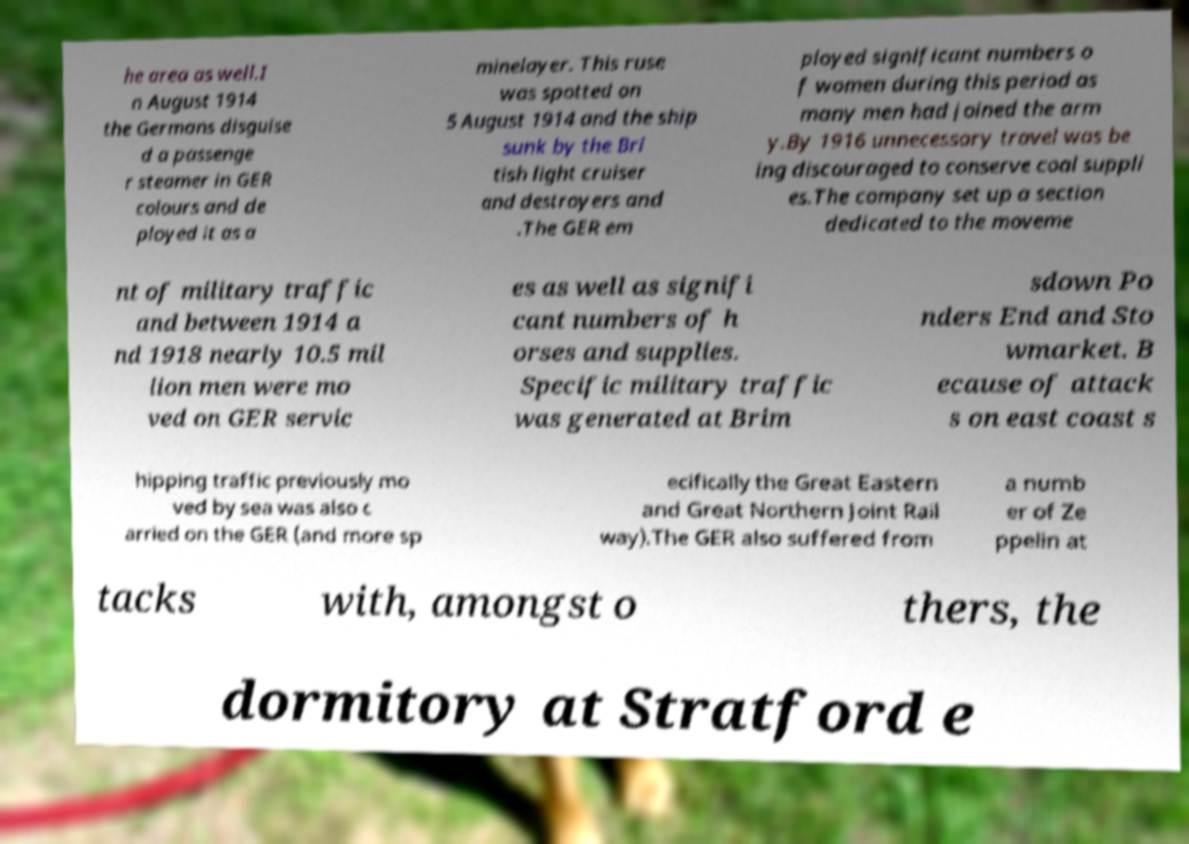Can you read and provide the text displayed in the image?This photo seems to have some interesting text. Can you extract and type it out for me? he area as well.I n August 1914 the Germans disguise d a passenge r steamer in GER colours and de ployed it as a minelayer. This ruse was spotted on 5 August 1914 and the ship sunk by the Bri tish light cruiser and destroyers and .The GER em ployed significant numbers o f women during this period as many men had joined the arm y.By 1916 unnecessary travel was be ing discouraged to conserve coal suppli es.The company set up a section dedicated to the moveme nt of military traffic and between 1914 a nd 1918 nearly 10.5 mil lion men were mo ved on GER servic es as well as signifi cant numbers of h orses and supplies. Specific military traffic was generated at Brim sdown Po nders End and Sto wmarket. B ecause of attack s on east coast s hipping traffic previously mo ved by sea was also c arried on the GER (and more sp ecifically the Great Eastern and Great Northern Joint Rail way).The GER also suffered from a numb er of Ze ppelin at tacks with, amongst o thers, the dormitory at Stratford e 